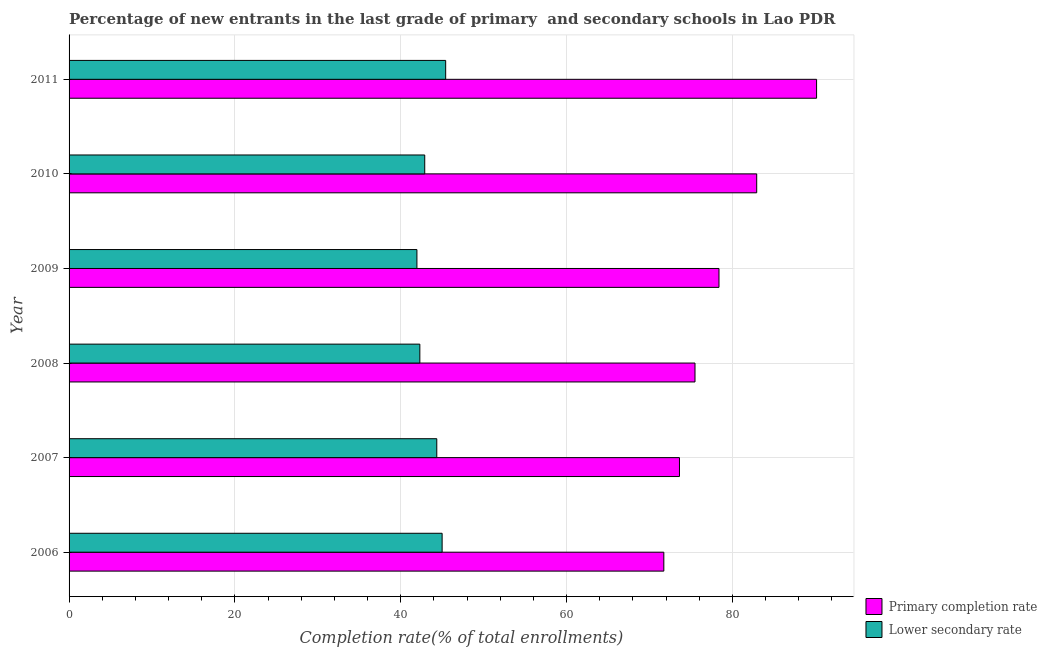How many different coloured bars are there?
Your response must be concise. 2. Are the number of bars on each tick of the Y-axis equal?
Ensure brevity in your answer.  Yes. How many bars are there on the 5th tick from the top?
Provide a short and direct response. 2. How many bars are there on the 1st tick from the bottom?
Ensure brevity in your answer.  2. In how many cases, is the number of bars for a given year not equal to the number of legend labels?
Your answer should be compact. 0. What is the completion rate in primary schools in 2011?
Offer a very short reply. 90.14. Across all years, what is the maximum completion rate in secondary schools?
Provide a succinct answer. 45.41. Across all years, what is the minimum completion rate in primary schools?
Provide a short and direct response. 71.72. In which year was the completion rate in secondary schools maximum?
Your answer should be compact. 2011. In which year was the completion rate in secondary schools minimum?
Provide a succinct answer. 2009. What is the total completion rate in primary schools in the graph?
Your answer should be compact. 472.26. What is the difference between the completion rate in primary schools in 2008 and that in 2011?
Give a very brief answer. -14.66. What is the difference between the completion rate in primary schools in 2008 and the completion rate in secondary schools in 2011?
Give a very brief answer. 30.07. What is the average completion rate in secondary schools per year?
Provide a succinct answer. 43.65. In the year 2011, what is the difference between the completion rate in secondary schools and completion rate in primary schools?
Ensure brevity in your answer.  -44.73. What is the ratio of the completion rate in primary schools in 2007 to that in 2008?
Your answer should be very brief. 0.97. What is the difference between the highest and the second highest completion rate in primary schools?
Provide a short and direct response. 7.22. What is the difference between the highest and the lowest completion rate in primary schools?
Give a very brief answer. 18.42. In how many years, is the completion rate in primary schools greater than the average completion rate in primary schools taken over all years?
Your answer should be compact. 2. Is the sum of the completion rate in primary schools in 2008 and 2009 greater than the maximum completion rate in secondary schools across all years?
Ensure brevity in your answer.  Yes. What does the 1st bar from the top in 2008 represents?
Give a very brief answer. Lower secondary rate. What does the 1st bar from the bottom in 2008 represents?
Keep it short and to the point. Primary completion rate. Are all the bars in the graph horizontal?
Offer a terse response. Yes. How many years are there in the graph?
Provide a short and direct response. 6. Does the graph contain grids?
Provide a succinct answer. Yes. How many legend labels are there?
Make the answer very short. 2. How are the legend labels stacked?
Ensure brevity in your answer.  Vertical. What is the title of the graph?
Offer a very short reply. Percentage of new entrants in the last grade of primary  and secondary schools in Lao PDR. What is the label or title of the X-axis?
Offer a very short reply. Completion rate(% of total enrollments). What is the label or title of the Y-axis?
Provide a succinct answer. Year. What is the Completion rate(% of total enrollments) in Primary completion rate in 2006?
Provide a short and direct response. 71.72. What is the Completion rate(% of total enrollments) of Lower secondary rate in 2006?
Ensure brevity in your answer.  44.99. What is the Completion rate(% of total enrollments) of Primary completion rate in 2007?
Offer a very short reply. 73.61. What is the Completion rate(% of total enrollments) in Lower secondary rate in 2007?
Ensure brevity in your answer.  44.34. What is the Completion rate(% of total enrollments) in Primary completion rate in 2008?
Your answer should be compact. 75.48. What is the Completion rate(% of total enrollments) of Lower secondary rate in 2008?
Your answer should be compact. 42.3. What is the Completion rate(% of total enrollments) in Primary completion rate in 2009?
Your answer should be very brief. 78.37. What is the Completion rate(% of total enrollments) of Lower secondary rate in 2009?
Your answer should be compact. 41.95. What is the Completion rate(% of total enrollments) in Primary completion rate in 2010?
Your response must be concise. 82.92. What is the Completion rate(% of total enrollments) in Lower secondary rate in 2010?
Provide a succinct answer. 42.89. What is the Completion rate(% of total enrollments) in Primary completion rate in 2011?
Provide a succinct answer. 90.14. What is the Completion rate(% of total enrollments) of Lower secondary rate in 2011?
Provide a succinct answer. 45.41. Across all years, what is the maximum Completion rate(% of total enrollments) of Primary completion rate?
Offer a very short reply. 90.14. Across all years, what is the maximum Completion rate(% of total enrollments) in Lower secondary rate?
Your answer should be compact. 45.41. Across all years, what is the minimum Completion rate(% of total enrollments) of Primary completion rate?
Make the answer very short. 71.72. Across all years, what is the minimum Completion rate(% of total enrollments) in Lower secondary rate?
Offer a terse response. 41.95. What is the total Completion rate(% of total enrollments) in Primary completion rate in the graph?
Provide a succinct answer. 472.26. What is the total Completion rate(% of total enrollments) in Lower secondary rate in the graph?
Provide a short and direct response. 261.88. What is the difference between the Completion rate(% of total enrollments) in Primary completion rate in 2006 and that in 2007?
Ensure brevity in your answer.  -1.89. What is the difference between the Completion rate(% of total enrollments) in Lower secondary rate in 2006 and that in 2007?
Make the answer very short. 0.64. What is the difference between the Completion rate(% of total enrollments) of Primary completion rate in 2006 and that in 2008?
Make the answer very short. -3.76. What is the difference between the Completion rate(% of total enrollments) of Lower secondary rate in 2006 and that in 2008?
Keep it short and to the point. 2.69. What is the difference between the Completion rate(% of total enrollments) of Primary completion rate in 2006 and that in 2009?
Provide a succinct answer. -6.65. What is the difference between the Completion rate(% of total enrollments) in Lower secondary rate in 2006 and that in 2009?
Offer a very short reply. 3.04. What is the difference between the Completion rate(% of total enrollments) of Primary completion rate in 2006 and that in 2010?
Your answer should be very brief. -11.2. What is the difference between the Completion rate(% of total enrollments) in Lower secondary rate in 2006 and that in 2010?
Provide a succinct answer. 2.1. What is the difference between the Completion rate(% of total enrollments) in Primary completion rate in 2006 and that in 2011?
Your answer should be very brief. -18.42. What is the difference between the Completion rate(% of total enrollments) of Lower secondary rate in 2006 and that in 2011?
Provide a short and direct response. -0.43. What is the difference between the Completion rate(% of total enrollments) of Primary completion rate in 2007 and that in 2008?
Provide a succinct answer. -1.87. What is the difference between the Completion rate(% of total enrollments) in Lower secondary rate in 2007 and that in 2008?
Offer a terse response. 2.04. What is the difference between the Completion rate(% of total enrollments) of Primary completion rate in 2007 and that in 2009?
Make the answer very short. -4.77. What is the difference between the Completion rate(% of total enrollments) of Lower secondary rate in 2007 and that in 2009?
Your answer should be very brief. 2.39. What is the difference between the Completion rate(% of total enrollments) in Primary completion rate in 2007 and that in 2010?
Provide a short and direct response. -9.31. What is the difference between the Completion rate(% of total enrollments) in Lower secondary rate in 2007 and that in 2010?
Your answer should be compact. 1.45. What is the difference between the Completion rate(% of total enrollments) in Primary completion rate in 2007 and that in 2011?
Offer a terse response. -16.53. What is the difference between the Completion rate(% of total enrollments) in Lower secondary rate in 2007 and that in 2011?
Give a very brief answer. -1.07. What is the difference between the Completion rate(% of total enrollments) in Primary completion rate in 2008 and that in 2009?
Your answer should be very brief. -2.89. What is the difference between the Completion rate(% of total enrollments) of Lower secondary rate in 2008 and that in 2009?
Provide a succinct answer. 0.35. What is the difference between the Completion rate(% of total enrollments) of Primary completion rate in 2008 and that in 2010?
Keep it short and to the point. -7.44. What is the difference between the Completion rate(% of total enrollments) in Lower secondary rate in 2008 and that in 2010?
Your answer should be compact. -0.59. What is the difference between the Completion rate(% of total enrollments) in Primary completion rate in 2008 and that in 2011?
Ensure brevity in your answer.  -14.66. What is the difference between the Completion rate(% of total enrollments) of Lower secondary rate in 2008 and that in 2011?
Your answer should be very brief. -3.11. What is the difference between the Completion rate(% of total enrollments) in Primary completion rate in 2009 and that in 2010?
Offer a terse response. -4.55. What is the difference between the Completion rate(% of total enrollments) in Lower secondary rate in 2009 and that in 2010?
Provide a short and direct response. -0.94. What is the difference between the Completion rate(% of total enrollments) of Primary completion rate in 2009 and that in 2011?
Your answer should be compact. -11.77. What is the difference between the Completion rate(% of total enrollments) in Lower secondary rate in 2009 and that in 2011?
Offer a very short reply. -3.47. What is the difference between the Completion rate(% of total enrollments) in Primary completion rate in 2010 and that in 2011?
Provide a short and direct response. -7.22. What is the difference between the Completion rate(% of total enrollments) in Lower secondary rate in 2010 and that in 2011?
Offer a terse response. -2.52. What is the difference between the Completion rate(% of total enrollments) in Primary completion rate in 2006 and the Completion rate(% of total enrollments) in Lower secondary rate in 2007?
Provide a succinct answer. 27.38. What is the difference between the Completion rate(% of total enrollments) in Primary completion rate in 2006 and the Completion rate(% of total enrollments) in Lower secondary rate in 2008?
Give a very brief answer. 29.42. What is the difference between the Completion rate(% of total enrollments) in Primary completion rate in 2006 and the Completion rate(% of total enrollments) in Lower secondary rate in 2009?
Give a very brief answer. 29.78. What is the difference between the Completion rate(% of total enrollments) of Primary completion rate in 2006 and the Completion rate(% of total enrollments) of Lower secondary rate in 2010?
Provide a short and direct response. 28.83. What is the difference between the Completion rate(% of total enrollments) in Primary completion rate in 2006 and the Completion rate(% of total enrollments) in Lower secondary rate in 2011?
Give a very brief answer. 26.31. What is the difference between the Completion rate(% of total enrollments) of Primary completion rate in 2007 and the Completion rate(% of total enrollments) of Lower secondary rate in 2008?
Offer a very short reply. 31.31. What is the difference between the Completion rate(% of total enrollments) of Primary completion rate in 2007 and the Completion rate(% of total enrollments) of Lower secondary rate in 2009?
Your answer should be very brief. 31.66. What is the difference between the Completion rate(% of total enrollments) in Primary completion rate in 2007 and the Completion rate(% of total enrollments) in Lower secondary rate in 2010?
Make the answer very short. 30.72. What is the difference between the Completion rate(% of total enrollments) of Primary completion rate in 2007 and the Completion rate(% of total enrollments) of Lower secondary rate in 2011?
Offer a terse response. 28.2. What is the difference between the Completion rate(% of total enrollments) in Primary completion rate in 2008 and the Completion rate(% of total enrollments) in Lower secondary rate in 2009?
Give a very brief answer. 33.53. What is the difference between the Completion rate(% of total enrollments) of Primary completion rate in 2008 and the Completion rate(% of total enrollments) of Lower secondary rate in 2010?
Provide a short and direct response. 32.59. What is the difference between the Completion rate(% of total enrollments) in Primary completion rate in 2008 and the Completion rate(% of total enrollments) in Lower secondary rate in 2011?
Offer a terse response. 30.07. What is the difference between the Completion rate(% of total enrollments) in Primary completion rate in 2009 and the Completion rate(% of total enrollments) in Lower secondary rate in 2010?
Give a very brief answer. 35.48. What is the difference between the Completion rate(% of total enrollments) in Primary completion rate in 2009 and the Completion rate(% of total enrollments) in Lower secondary rate in 2011?
Keep it short and to the point. 32.96. What is the difference between the Completion rate(% of total enrollments) of Primary completion rate in 2010 and the Completion rate(% of total enrollments) of Lower secondary rate in 2011?
Ensure brevity in your answer.  37.51. What is the average Completion rate(% of total enrollments) of Primary completion rate per year?
Provide a succinct answer. 78.71. What is the average Completion rate(% of total enrollments) of Lower secondary rate per year?
Offer a terse response. 43.65. In the year 2006, what is the difference between the Completion rate(% of total enrollments) in Primary completion rate and Completion rate(% of total enrollments) in Lower secondary rate?
Give a very brief answer. 26.74. In the year 2007, what is the difference between the Completion rate(% of total enrollments) in Primary completion rate and Completion rate(% of total enrollments) in Lower secondary rate?
Give a very brief answer. 29.27. In the year 2008, what is the difference between the Completion rate(% of total enrollments) of Primary completion rate and Completion rate(% of total enrollments) of Lower secondary rate?
Offer a terse response. 33.18. In the year 2009, what is the difference between the Completion rate(% of total enrollments) of Primary completion rate and Completion rate(% of total enrollments) of Lower secondary rate?
Provide a succinct answer. 36.43. In the year 2010, what is the difference between the Completion rate(% of total enrollments) in Primary completion rate and Completion rate(% of total enrollments) in Lower secondary rate?
Your response must be concise. 40.03. In the year 2011, what is the difference between the Completion rate(% of total enrollments) of Primary completion rate and Completion rate(% of total enrollments) of Lower secondary rate?
Your answer should be compact. 44.73. What is the ratio of the Completion rate(% of total enrollments) of Primary completion rate in 2006 to that in 2007?
Offer a terse response. 0.97. What is the ratio of the Completion rate(% of total enrollments) of Lower secondary rate in 2006 to that in 2007?
Your answer should be very brief. 1.01. What is the ratio of the Completion rate(% of total enrollments) of Primary completion rate in 2006 to that in 2008?
Ensure brevity in your answer.  0.95. What is the ratio of the Completion rate(% of total enrollments) of Lower secondary rate in 2006 to that in 2008?
Make the answer very short. 1.06. What is the ratio of the Completion rate(% of total enrollments) of Primary completion rate in 2006 to that in 2009?
Offer a terse response. 0.92. What is the ratio of the Completion rate(% of total enrollments) of Lower secondary rate in 2006 to that in 2009?
Offer a terse response. 1.07. What is the ratio of the Completion rate(% of total enrollments) of Primary completion rate in 2006 to that in 2010?
Provide a succinct answer. 0.86. What is the ratio of the Completion rate(% of total enrollments) of Lower secondary rate in 2006 to that in 2010?
Keep it short and to the point. 1.05. What is the ratio of the Completion rate(% of total enrollments) in Primary completion rate in 2006 to that in 2011?
Your response must be concise. 0.8. What is the ratio of the Completion rate(% of total enrollments) of Lower secondary rate in 2006 to that in 2011?
Keep it short and to the point. 0.99. What is the ratio of the Completion rate(% of total enrollments) in Primary completion rate in 2007 to that in 2008?
Make the answer very short. 0.98. What is the ratio of the Completion rate(% of total enrollments) of Lower secondary rate in 2007 to that in 2008?
Offer a terse response. 1.05. What is the ratio of the Completion rate(% of total enrollments) in Primary completion rate in 2007 to that in 2009?
Your answer should be very brief. 0.94. What is the ratio of the Completion rate(% of total enrollments) in Lower secondary rate in 2007 to that in 2009?
Offer a very short reply. 1.06. What is the ratio of the Completion rate(% of total enrollments) in Primary completion rate in 2007 to that in 2010?
Offer a terse response. 0.89. What is the ratio of the Completion rate(% of total enrollments) in Lower secondary rate in 2007 to that in 2010?
Give a very brief answer. 1.03. What is the ratio of the Completion rate(% of total enrollments) of Primary completion rate in 2007 to that in 2011?
Ensure brevity in your answer.  0.82. What is the ratio of the Completion rate(% of total enrollments) of Lower secondary rate in 2007 to that in 2011?
Provide a succinct answer. 0.98. What is the ratio of the Completion rate(% of total enrollments) of Primary completion rate in 2008 to that in 2009?
Your answer should be very brief. 0.96. What is the ratio of the Completion rate(% of total enrollments) of Lower secondary rate in 2008 to that in 2009?
Ensure brevity in your answer.  1.01. What is the ratio of the Completion rate(% of total enrollments) in Primary completion rate in 2008 to that in 2010?
Ensure brevity in your answer.  0.91. What is the ratio of the Completion rate(% of total enrollments) of Lower secondary rate in 2008 to that in 2010?
Your answer should be very brief. 0.99. What is the ratio of the Completion rate(% of total enrollments) in Primary completion rate in 2008 to that in 2011?
Keep it short and to the point. 0.84. What is the ratio of the Completion rate(% of total enrollments) in Lower secondary rate in 2008 to that in 2011?
Offer a terse response. 0.93. What is the ratio of the Completion rate(% of total enrollments) of Primary completion rate in 2009 to that in 2010?
Your response must be concise. 0.95. What is the ratio of the Completion rate(% of total enrollments) of Primary completion rate in 2009 to that in 2011?
Your answer should be very brief. 0.87. What is the ratio of the Completion rate(% of total enrollments) in Lower secondary rate in 2009 to that in 2011?
Keep it short and to the point. 0.92. What is the ratio of the Completion rate(% of total enrollments) of Primary completion rate in 2010 to that in 2011?
Keep it short and to the point. 0.92. What is the difference between the highest and the second highest Completion rate(% of total enrollments) in Primary completion rate?
Keep it short and to the point. 7.22. What is the difference between the highest and the second highest Completion rate(% of total enrollments) of Lower secondary rate?
Your response must be concise. 0.43. What is the difference between the highest and the lowest Completion rate(% of total enrollments) of Primary completion rate?
Ensure brevity in your answer.  18.42. What is the difference between the highest and the lowest Completion rate(% of total enrollments) of Lower secondary rate?
Give a very brief answer. 3.47. 